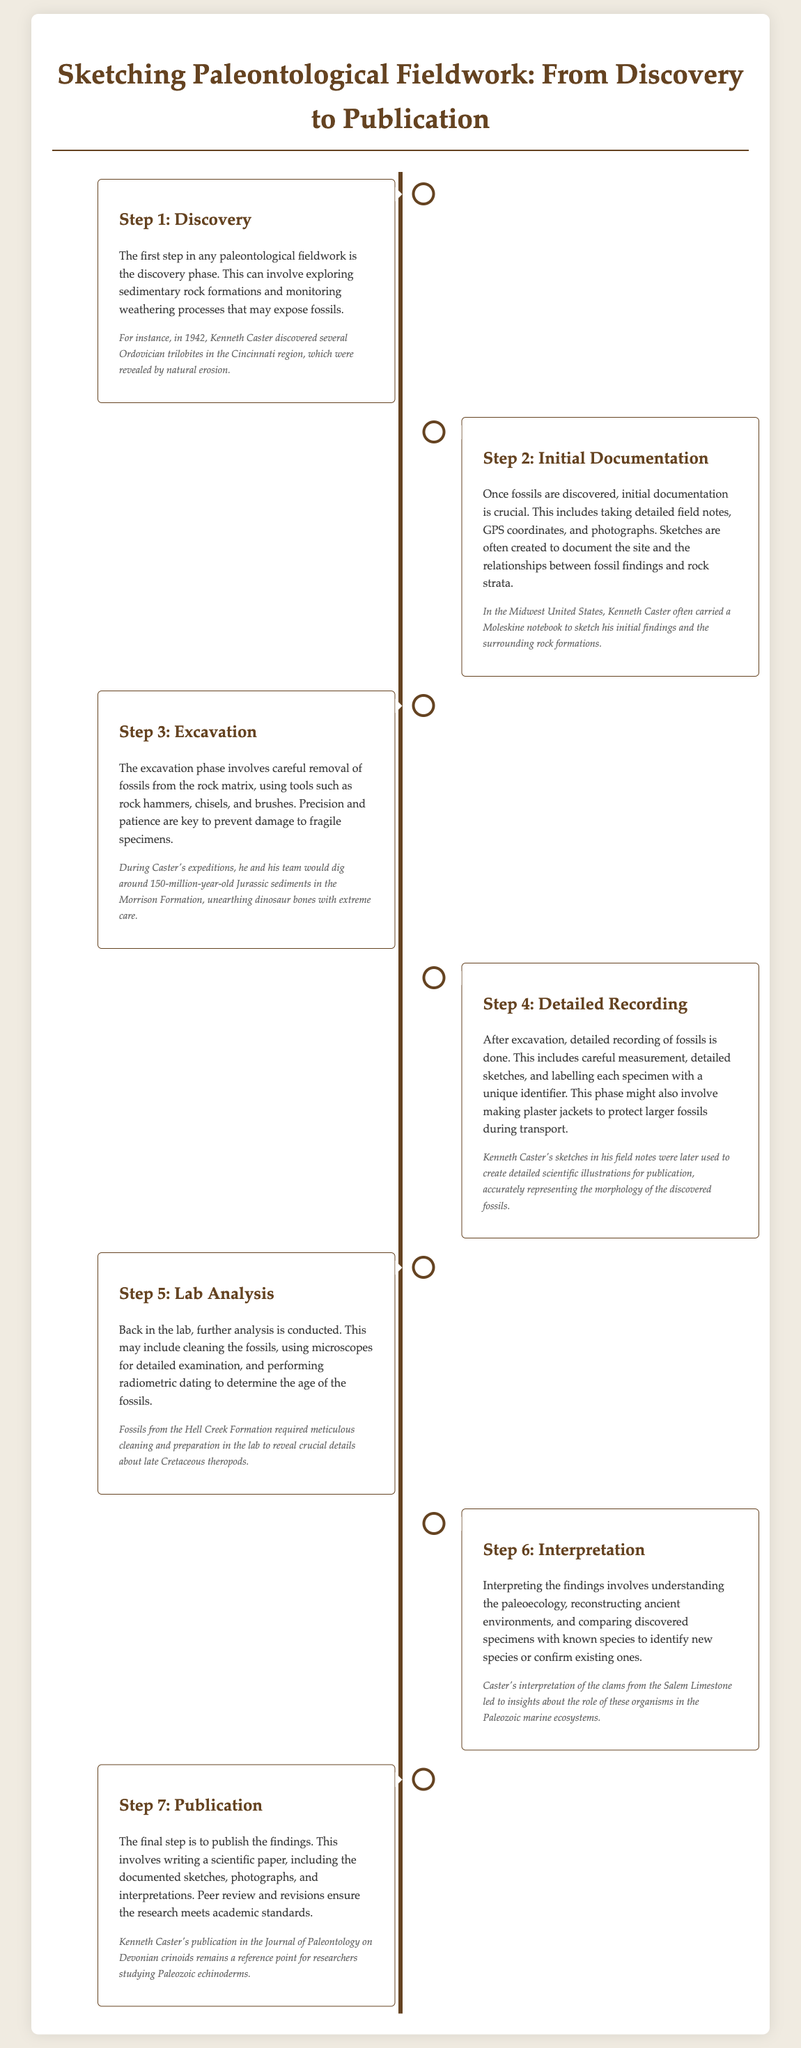What is the first step in paleontological fieldwork? The first step outlined in the document is the discovery phase, which involves exploring sedimentary rock formations and monitoring weathering processes.
Answer: Discovery In which year did Kenneth Caster discover Ordovician trilobites? The document mentions that Kenneth Caster discovered several Ordovician trilobites in 1942.
Answer: 1942 What phase follows initial documentation? According to the document, the excavation phase follows initial documentation.
Answer: Excavation What is a key tool mentioned for excavation? The document lists rock hammers, chisels, and brushes as key tools for excavation.
Answer: Brushes What activity is involved in the lab analysis phase? The lab analysis phase involves cleaning the fossils, using microscopes, and performing radiometric dating.
Answer: Cleaning Which formation required meticulous cleaning and preparation? The document specifies that fossils from the Hell Creek Formation required meticulous cleaning and preparation.
Answer: Hell Creek Formation What is the last step of the process? The final step of the process described in the document is publication.
Answer: Publication What was Kenneth Caster's publication in the Journal of Paleontology about? The document states that Kenneth Caster's publication in the Journal of Paleontology was on Devonian crinoids.
Answer: Devonian crinoids What is the significance of recording fossils in the field? The document indicates that recording fossils includes careful measurement, detailed sketches, and labelling, which is vital for scientific accuracy.
Answer: Vital for scientific accuracy 